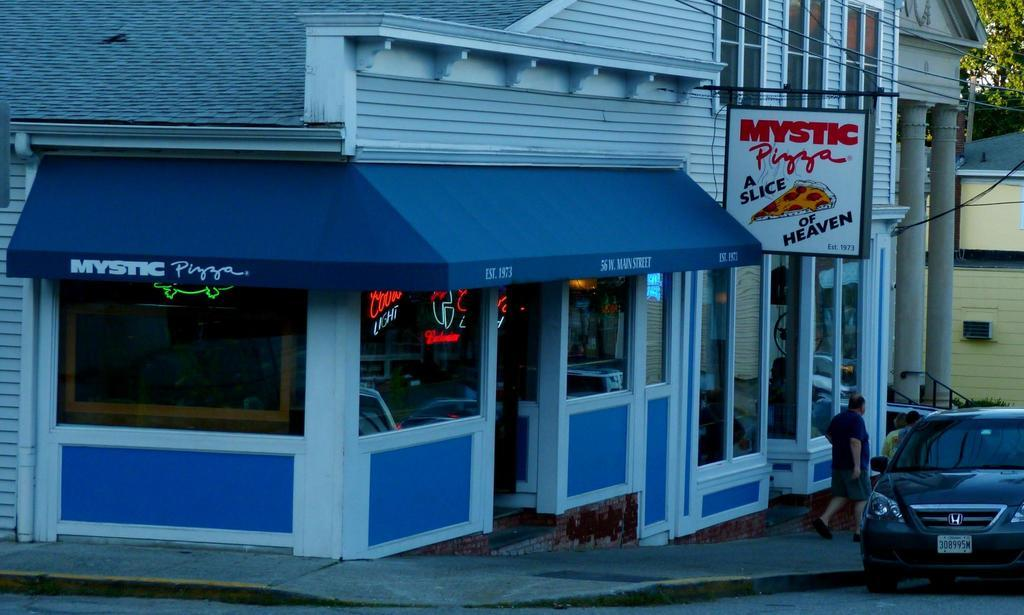What type of structures can be seen in the image? There are buildings in the image. What natural elements are present in the image? There are trees in the image. What man-made objects can be seen in the image? Cables are visible in the image. Who or what is present in the image besides the buildings and trees? There is a group of people and a car on the right side of the image. What type of advertisement or signage is present in the image? There is a hoarding in the image. What type of rings are being worn by the trees in the image? There are no rings visible on the trees in the image. What are the people in the image learning about? The image does not provide information about what the people are learning. 